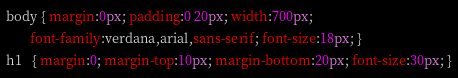<code> <loc_0><loc_0><loc_500><loc_500><_CSS_>body { margin:0px; padding:0 20px; width:700px;
       font-family:verdana,arial,sans-serif; font-size:18px; }
h1   { margin:0; margin-top:10px; margin-bottom:20px; font-size:30px; }
</code> 